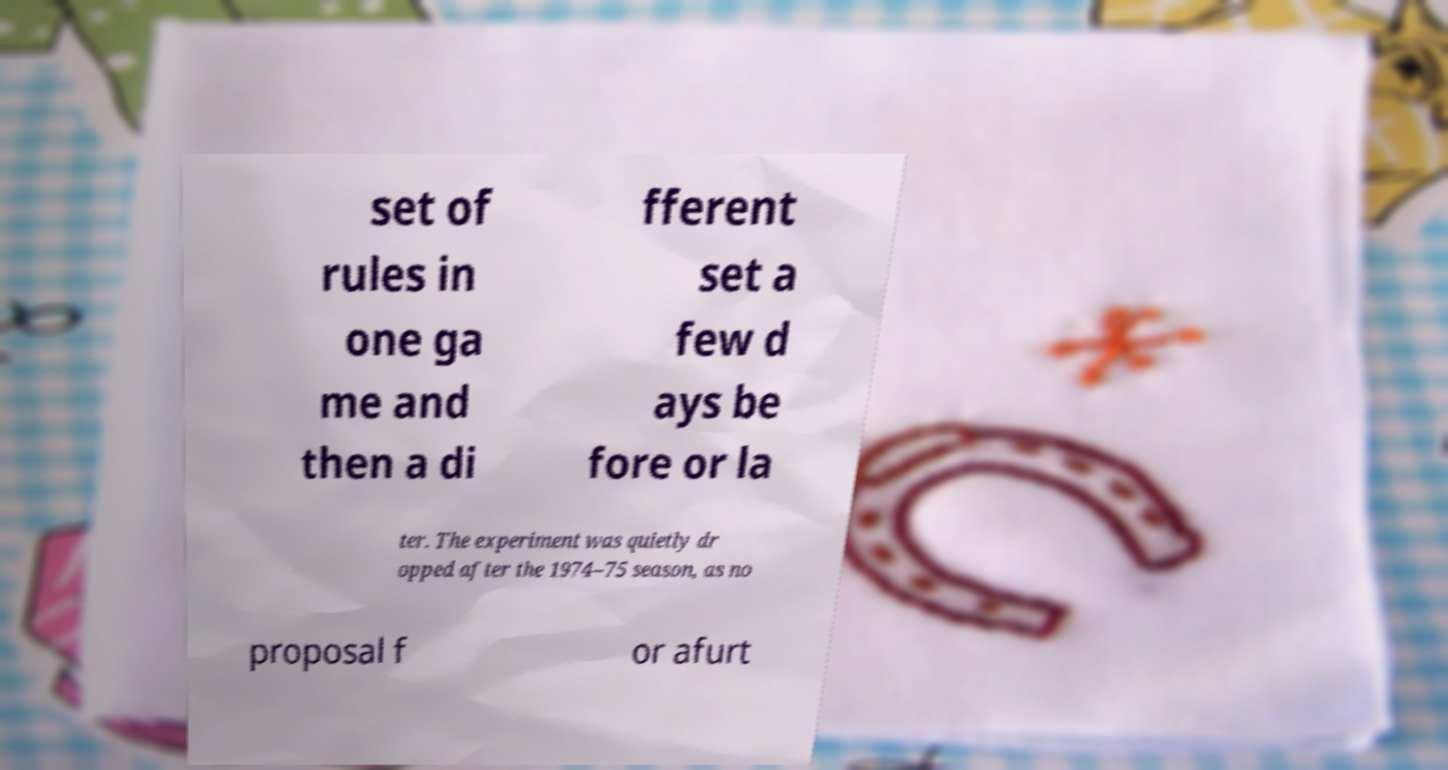Please read and relay the text visible in this image. What does it say? set of rules in one ga me and then a di fferent set a few d ays be fore or la ter. The experiment was quietly dr opped after the 1974–75 season, as no proposal f or afurt 